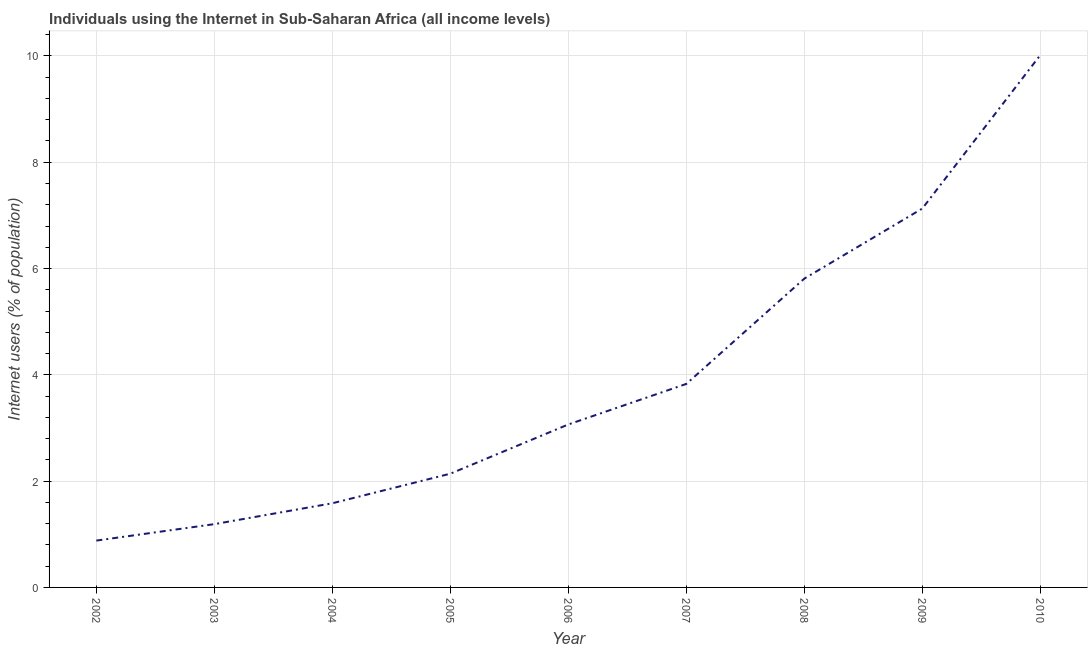What is the number of internet users in 2003?
Your answer should be very brief. 1.19. Across all years, what is the maximum number of internet users?
Make the answer very short. 10.02. Across all years, what is the minimum number of internet users?
Ensure brevity in your answer.  0.88. In which year was the number of internet users maximum?
Offer a terse response. 2010. In which year was the number of internet users minimum?
Give a very brief answer. 2002. What is the sum of the number of internet users?
Provide a short and direct response. 35.65. What is the difference between the number of internet users in 2004 and 2008?
Keep it short and to the point. -4.23. What is the average number of internet users per year?
Offer a very short reply. 3.96. What is the median number of internet users?
Your answer should be very brief. 3.07. Do a majority of the years between 2010 and 2007 (inclusive) have number of internet users greater than 10 %?
Make the answer very short. Yes. What is the ratio of the number of internet users in 2002 to that in 2004?
Your answer should be compact. 0.56. Is the difference between the number of internet users in 2002 and 2008 greater than the difference between any two years?
Keep it short and to the point. No. What is the difference between the highest and the second highest number of internet users?
Give a very brief answer. 2.89. What is the difference between the highest and the lowest number of internet users?
Provide a short and direct response. 9.13. In how many years, is the number of internet users greater than the average number of internet users taken over all years?
Make the answer very short. 3. How many lines are there?
Give a very brief answer. 1. How many years are there in the graph?
Make the answer very short. 9. What is the difference between two consecutive major ticks on the Y-axis?
Your answer should be very brief. 2. What is the title of the graph?
Your answer should be compact. Individuals using the Internet in Sub-Saharan Africa (all income levels). What is the label or title of the X-axis?
Your answer should be very brief. Year. What is the label or title of the Y-axis?
Your response must be concise. Internet users (% of population). What is the Internet users (% of population) of 2002?
Your answer should be compact. 0.88. What is the Internet users (% of population) of 2003?
Offer a terse response. 1.19. What is the Internet users (% of population) in 2004?
Your answer should be very brief. 1.58. What is the Internet users (% of population) of 2005?
Offer a very short reply. 2.14. What is the Internet users (% of population) in 2006?
Your answer should be very brief. 3.07. What is the Internet users (% of population) in 2007?
Give a very brief answer. 3.83. What is the Internet users (% of population) of 2008?
Your answer should be compact. 5.81. What is the Internet users (% of population) in 2009?
Ensure brevity in your answer.  7.13. What is the Internet users (% of population) in 2010?
Provide a succinct answer. 10.02. What is the difference between the Internet users (% of population) in 2002 and 2003?
Ensure brevity in your answer.  -0.31. What is the difference between the Internet users (% of population) in 2002 and 2004?
Your response must be concise. -0.7. What is the difference between the Internet users (% of population) in 2002 and 2005?
Give a very brief answer. -1.26. What is the difference between the Internet users (% of population) in 2002 and 2006?
Your answer should be compact. -2.18. What is the difference between the Internet users (% of population) in 2002 and 2007?
Make the answer very short. -2.95. What is the difference between the Internet users (% of population) in 2002 and 2008?
Make the answer very short. -4.93. What is the difference between the Internet users (% of population) in 2002 and 2009?
Your answer should be very brief. -6.25. What is the difference between the Internet users (% of population) in 2002 and 2010?
Offer a very short reply. -9.13. What is the difference between the Internet users (% of population) in 2003 and 2004?
Offer a terse response. -0.39. What is the difference between the Internet users (% of population) in 2003 and 2005?
Offer a very short reply. -0.95. What is the difference between the Internet users (% of population) in 2003 and 2006?
Make the answer very short. -1.88. What is the difference between the Internet users (% of population) in 2003 and 2007?
Provide a short and direct response. -2.64. What is the difference between the Internet users (% of population) in 2003 and 2008?
Ensure brevity in your answer.  -4.62. What is the difference between the Internet users (% of population) in 2003 and 2009?
Your answer should be compact. -5.94. What is the difference between the Internet users (% of population) in 2003 and 2010?
Your response must be concise. -8.82. What is the difference between the Internet users (% of population) in 2004 and 2005?
Ensure brevity in your answer.  -0.56. What is the difference between the Internet users (% of population) in 2004 and 2006?
Offer a terse response. -1.48. What is the difference between the Internet users (% of population) in 2004 and 2007?
Your response must be concise. -2.25. What is the difference between the Internet users (% of population) in 2004 and 2008?
Your response must be concise. -4.23. What is the difference between the Internet users (% of population) in 2004 and 2009?
Provide a succinct answer. -5.55. What is the difference between the Internet users (% of population) in 2004 and 2010?
Your answer should be very brief. -8.43. What is the difference between the Internet users (% of population) in 2005 and 2006?
Your answer should be very brief. -0.93. What is the difference between the Internet users (% of population) in 2005 and 2007?
Offer a very short reply. -1.69. What is the difference between the Internet users (% of population) in 2005 and 2008?
Your answer should be compact. -3.67. What is the difference between the Internet users (% of population) in 2005 and 2009?
Keep it short and to the point. -4.99. What is the difference between the Internet users (% of population) in 2005 and 2010?
Make the answer very short. -7.88. What is the difference between the Internet users (% of population) in 2006 and 2007?
Your response must be concise. -0.76. What is the difference between the Internet users (% of population) in 2006 and 2008?
Keep it short and to the point. -2.74. What is the difference between the Internet users (% of population) in 2006 and 2009?
Offer a terse response. -4.06. What is the difference between the Internet users (% of population) in 2006 and 2010?
Keep it short and to the point. -6.95. What is the difference between the Internet users (% of population) in 2007 and 2008?
Ensure brevity in your answer.  -1.98. What is the difference between the Internet users (% of population) in 2007 and 2009?
Offer a very short reply. -3.3. What is the difference between the Internet users (% of population) in 2007 and 2010?
Offer a terse response. -6.19. What is the difference between the Internet users (% of population) in 2008 and 2009?
Offer a very short reply. -1.32. What is the difference between the Internet users (% of population) in 2008 and 2010?
Make the answer very short. -4.21. What is the difference between the Internet users (% of population) in 2009 and 2010?
Give a very brief answer. -2.89. What is the ratio of the Internet users (% of population) in 2002 to that in 2003?
Ensure brevity in your answer.  0.74. What is the ratio of the Internet users (% of population) in 2002 to that in 2004?
Provide a succinct answer. 0.56. What is the ratio of the Internet users (% of population) in 2002 to that in 2005?
Offer a terse response. 0.41. What is the ratio of the Internet users (% of population) in 2002 to that in 2006?
Offer a very short reply. 0.29. What is the ratio of the Internet users (% of population) in 2002 to that in 2007?
Make the answer very short. 0.23. What is the ratio of the Internet users (% of population) in 2002 to that in 2008?
Offer a terse response. 0.15. What is the ratio of the Internet users (% of population) in 2002 to that in 2009?
Ensure brevity in your answer.  0.12. What is the ratio of the Internet users (% of population) in 2002 to that in 2010?
Ensure brevity in your answer.  0.09. What is the ratio of the Internet users (% of population) in 2003 to that in 2004?
Provide a short and direct response. 0.75. What is the ratio of the Internet users (% of population) in 2003 to that in 2005?
Offer a terse response. 0.56. What is the ratio of the Internet users (% of population) in 2003 to that in 2006?
Your response must be concise. 0.39. What is the ratio of the Internet users (% of population) in 2003 to that in 2007?
Give a very brief answer. 0.31. What is the ratio of the Internet users (% of population) in 2003 to that in 2008?
Make the answer very short. 0.2. What is the ratio of the Internet users (% of population) in 2003 to that in 2009?
Ensure brevity in your answer.  0.17. What is the ratio of the Internet users (% of population) in 2003 to that in 2010?
Your answer should be very brief. 0.12. What is the ratio of the Internet users (% of population) in 2004 to that in 2005?
Your response must be concise. 0.74. What is the ratio of the Internet users (% of population) in 2004 to that in 2006?
Your response must be concise. 0.52. What is the ratio of the Internet users (% of population) in 2004 to that in 2007?
Your answer should be compact. 0.41. What is the ratio of the Internet users (% of population) in 2004 to that in 2008?
Offer a terse response. 0.27. What is the ratio of the Internet users (% of population) in 2004 to that in 2009?
Offer a terse response. 0.22. What is the ratio of the Internet users (% of population) in 2004 to that in 2010?
Give a very brief answer. 0.16. What is the ratio of the Internet users (% of population) in 2005 to that in 2006?
Provide a short and direct response. 0.7. What is the ratio of the Internet users (% of population) in 2005 to that in 2007?
Your answer should be very brief. 0.56. What is the ratio of the Internet users (% of population) in 2005 to that in 2008?
Offer a terse response. 0.37. What is the ratio of the Internet users (% of population) in 2005 to that in 2010?
Your answer should be very brief. 0.21. What is the ratio of the Internet users (% of population) in 2006 to that in 2007?
Provide a short and direct response. 0.8. What is the ratio of the Internet users (% of population) in 2006 to that in 2008?
Your response must be concise. 0.53. What is the ratio of the Internet users (% of population) in 2006 to that in 2009?
Provide a succinct answer. 0.43. What is the ratio of the Internet users (% of population) in 2006 to that in 2010?
Give a very brief answer. 0.31. What is the ratio of the Internet users (% of population) in 2007 to that in 2008?
Offer a very short reply. 0.66. What is the ratio of the Internet users (% of population) in 2007 to that in 2009?
Make the answer very short. 0.54. What is the ratio of the Internet users (% of population) in 2007 to that in 2010?
Provide a short and direct response. 0.38. What is the ratio of the Internet users (% of population) in 2008 to that in 2009?
Provide a succinct answer. 0.81. What is the ratio of the Internet users (% of population) in 2008 to that in 2010?
Your answer should be compact. 0.58. What is the ratio of the Internet users (% of population) in 2009 to that in 2010?
Your response must be concise. 0.71. 